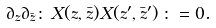Convert formula to latex. <formula><loc_0><loc_0><loc_500><loc_500>\partial _ { z } \partial _ { \bar { z } } { \colon \, X ( z , \bar { z } ) X ( z ^ { \prime } , \bar { z } ^ { \prime } ) \, \colon } = 0 .</formula> 